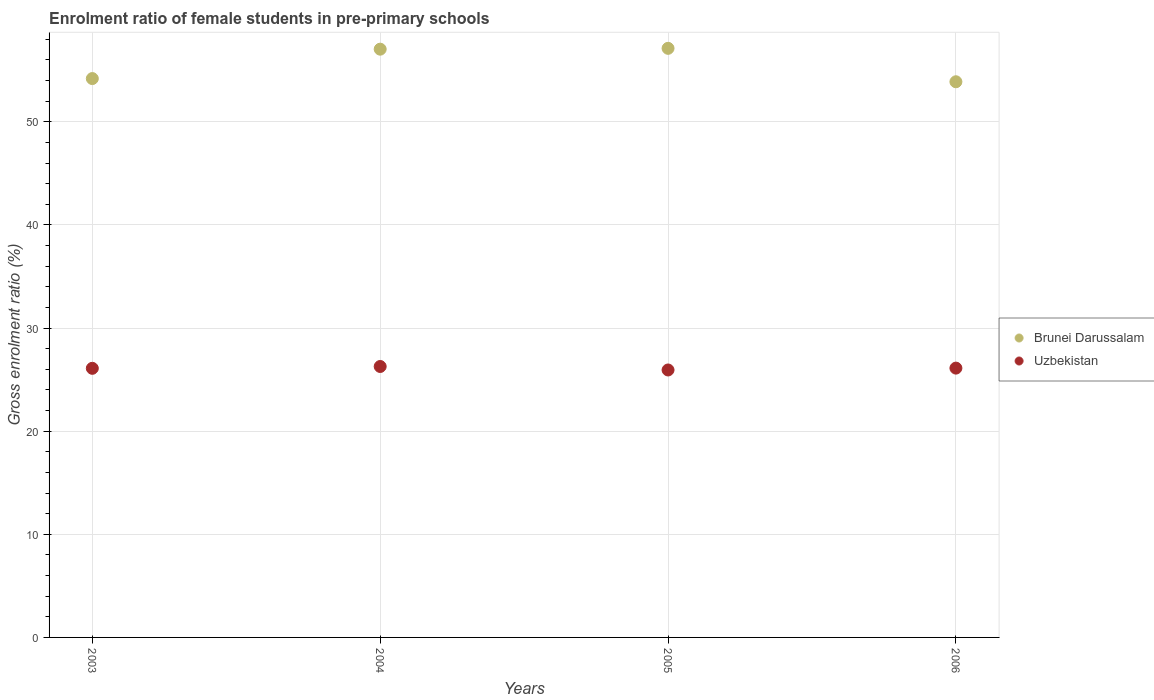Is the number of dotlines equal to the number of legend labels?
Offer a terse response. Yes. What is the enrolment ratio of female students in pre-primary schools in Brunei Darussalam in 2004?
Your response must be concise. 57.04. Across all years, what is the maximum enrolment ratio of female students in pre-primary schools in Brunei Darussalam?
Give a very brief answer. 57.12. Across all years, what is the minimum enrolment ratio of female students in pre-primary schools in Uzbekistan?
Offer a very short reply. 25.93. What is the total enrolment ratio of female students in pre-primary schools in Uzbekistan in the graph?
Make the answer very short. 104.41. What is the difference between the enrolment ratio of female students in pre-primary schools in Uzbekistan in 2003 and that in 2006?
Ensure brevity in your answer.  -0.02. What is the difference between the enrolment ratio of female students in pre-primary schools in Uzbekistan in 2006 and the enrolment ratio of female students in pre-primary schools in Brunei Darussalam in 2004?
Keep it short and to the point. -30.92. What is the average enrolment ratio of female students in pre-primary schools in Brunei Darussalam per year?
Give a very brief answer. 55.56. In the year 2005, what is the difference between the enrolment ratio of female students in pre-primary schools in Brunei Darussalam and enrolment ratio of female students in pre-primary schools in Uzbekistan?
Provide a succinct answer. 31.19. In how many years, is the enrolment ratio of female students in pre-primary schools in Uzbekistan greater than 2 %?
Your response must be concise. 4. What is the ratio of the enrolment ratio of female students in pre-primary schools in Uzbekistan in 2004 to that in 2005?
Your answer should be compact. 1.01. What is the difference between the highest and the second highest enrolment ratio of female students in pre-primary schools in Uzbekistan?
Your answer should be very brief. 0.16. What is the difference between the highest and the lowest enrolment ratio of female students in pre-primary schools in Uzbekistan?
Provide a succinct answer. 0.34. In how many years, is the enrolment ratio of female students in pre-primary schools in Brunei Darussalam greater than the average enrolment ratio of female students in pre-primary schools in Brunei Darussalam taken over all years?
Offer a very short reply. 2. Does the enrolment ratio of female students in pre-primary schools in Uzbekistan monotonically increase over the years?
Offer a terse response. No. Is the enrolment ratio of female students in pre-primary schools in Uzbekistan strictly less than the enrolment ratio of female students in pre-primary schools in Brunei Darussalam over the years?
Offer a terse response. Yes. How many dotlines are there?
Offer a terse response. 2. How many years are there in the graph?
Provide a short and direct response. 4. What is the difference between two consecutive major ticks on the Y-axis?
Ensure brevity in your answer.  10. Are the values on the major ticks of Y-axis written in scientific E-notation?
Provide a short and direct response. No. Does the graph contain any zero values?
Your answer should be compact. No. Where does the legend appear in the graph?
Give a very brief answer. Center right. How many legend labels are there?
Provide a short and direct response. 2. How are the legend labels stacked?
Make the answer very short. Vertical. What is the title of the graph?
Keep it short and to the point. Enrolment ratio of female students in pre-primary schools. Does "Djibouti" appear as one of the legend labels in the graph?
Make the answer very short. No. What is the label or title of the X-axis?
Your answer should be very brief. Years. What is the Gross enrolment ratio (%) of Brunei Darussalam in 2003?
Keep it short and to the point. 54.19. What is the Gross enrolment ratio (%) in Uzbekistan in 2003?
Make the answer very short. 26.09. What is the Gross enrolment ratio (%) of Brunei Darussalam in 2004?
Give a very brief answer. 57.04. What is the Gross enrolment ratio (%) of Uzbekistan in 2004?
Your response must be concise. 26.27. What is the Gross enrolment ratio (%) in Brunei Darussalam in 2005?
Make the answer very short. 57.12. What is the Gross enrolment ratio (%) in Uzbekistan in 2005?
Give a very brief answer. 25.93. What is the Gross enrolment ratio (%) of Brunei Darussalam in 2006?
Ensure brevity in your answer.  53.88. What is the Gross enrolment ratio (%) of Uzbekistan in 2006?
Make the answer very short. 26.11. Across all years, what is the maximum Gross enrolment ratio (%) in Brunei Darussalam?
Your answer should be compact. 57.12. Across all years, what is the maximum Gross enrolment ratio (%) of Uzbekistan?
Make the answer very short. 26.27. Across all years, what is the minimum Gross enrolment ratio (%) in Brunei Darussalam?
Give a very brief answer. 53.88. Across all years, what is the minimum Gross enrolment ratio (%) of Uzbekistan?
Your response must be concise. 25.93. What is the total Gross enrolment ratio (%) of Brunei Darussalam in the graph?
Give a very brief answer. 222.22. What is the total Gross enrolment ratio (%) in Uzbekistan in the graph?
Provide a succinct answer. 104.41. What is the difference between the Gross enrolment ratio (%) of Brunei Darussalam in 2003 and that in 2004?
Ensure brevity in your answer.  -2.85. What is the difference between the Gross enrolment ratio (%) of Uzbekistan in 2003 and that in 2004?
Keep it short and to the point. -0.18. What is the difference between the Gross enrolment ratio (%) of Brunei Darussalam in 2003 and that in 2005?
Your response must be concise. -2.93. What is the difference between the Gross enrolment ratio (%) in Uzbekistan in 2003 and that in 2005?
Your answer should be very brief. 0.16. What is the difference between the Gross enrolment ratio (%) of Brunei Darussalam in 2003 and that in 2006?
Keep it short and to the point. 0.31. What is the difference between the Gross enrolment ratio (%) of Uzbekistan in 2003 and that in 2006?
Your response must be concise. -0.02. What is the difference between the Gross enrolment ratio (%) of Brunei Darussalam in 2004 and that in 2005?
Ensure brevity in your answer.  -0.08. What is the difference between the Gross enrolment ratio (%) of Uzbekistan in 2004 and that in 2005?
Your answer should be compact. 0.34. What is the difference between the Gross enrolment ratio (%) in Brunei Darussalam in 2004 and that in 2006?
Make the answer very short. 3.16. What is the difference between the Gross enrolment ratio (%) of Uzbekistan in 2004 and that in 2006?
Give a very brief answer. 0.16. What is the difference between the Gross enrolment ratio (%) in Brunei Darussalam in 2005 and that in 2006?
Keep it short and to the point. 3.24. What is the difference between the Gross enrolment ratio (%) of Uzbekistan in 2005 and that in 2006?
Your answer should be compact. -0.18. What is the difference between the Gross enrolment ratio (%) in Brunei Darussalam in 2003 and the Gross enrolment ratio (%) in Uzbekistan in 2004?
Your response must be concise. 27.92. What is the difference between the Gross enrolment ratio (%) in Brunei Darussalam in 2003 and the Gross enrolment ratio (%) in Uzbekistan in 2005?
Your answer should be very brief. 28.25. What is the difference between the Gross enrolment ratio (%) in Brunei Darussalam in 2003 and the Gross enrolment ratio (%) in Uzbekistan in 2006?
Ensure brevity in your answer.  28.07. What is the difference between the Gross enrolment ratio (%) in Brunei Darussalam in 2004 and the Gross enrolment ratio (%) in Uzbekistan in 2005?
Your answer should be compact. 31.11. What is the difference between the Gross enrolment ratio (%) in Brunei Darussalam in 2004 and the Gross enrolment ratio (%) in Uzbekistan in 2006?
Provide a succinct answer. 30.92. What is the difference between the Gross enrolment ratio (%) in Brunei Darussalam in 2005 and the Gross enrolment ratio (%) in Uzbekistan in 2006?
Give a very brief answer. 31.01. What is the average Gross enrolment ratio (%) in Brunei Darussalam per year?
Keep it short and to the point. 55.56. What is the average Gross enrolment ratio (%) in Uzbekistan per year?
Offer a terse response. 26.1. In the year 2003, what is the difference between the Gross enrolment ratio (%) in Brunei Darussalam and Gross enrolment ratio (%) in Uzbekistan?
Keep it short and to the point. 28.09. In the year 2004, what is the difference between the Gross enrolment ratio (%) of Brunei Darussalam and Gross enrolment ratio (%) of Uzbekistan?
Your answer should be compact. 30.77. In the year 2005, what is the difference between the Gross enrolment ratio (%) in Brunei Darussalam and Gross enrolment ratio (%) in Uzbekistan?
Give a very brief answer. 31.19. In the year 2006, what is the difference between the Gross enrolment ratio (%) in Brunei Darussalam and Gross enrolment ratio (%) in Uzbekistan?
Keep it short and to the point. 27.76. What is the ratio of the Gross enrolment ratio (%) of Brunei Darussalam in 2003 to that in 2004?
Your response must be concise. 0.95. What is the ratio of the Gross enrolment ratio (%) in Uzbekistan in 2003 to that in 2004?
Offer a very short reply. 0.99. What is the ratio of the Gross enrolment ratio (%) of Brunei Darussalam in 2003 to that in 2005?
Your answer should be very brief. 0.95. What is the ratio of the Gross enrolment ratio (%) of Brunei Darussalam in 2004 to that in 2005?
Offer a terse response. 1. What is the ratio of the Gross enrolment ratio (%) in Uzbekistan in 2004 to that in 2005?
Provide a succinct answer. 1.01. What is the ratio of the Gross enrolment ratio (%) of Brunei Darussalam in 2004 to that in 2006?
Provide a succinct answer. 1.06. What is the ratio of the Gross enrolment ratio (%) in Brunei Darussalam in 2005 to that in 2006?
Ensure brevity in your answer.  1.06. What is the ratio of the Gross enrolment ratio (%) in Uzbekistan in 2005 to that in 2006?
Your response must be concise. 0.99. What is the difference between the highest and the second highest Gross enrolment ratio (%) in Brunei Darussalam?
Provide a succinct answer. 0.08. What is the difference between the highest and the second highest Gross enrolment ratio (%) of Uzbekistan?
Ensure brevity in your answer.  0.16. What is the difference between the highest and the lowest Gross enrolment ratio (%) in Brunei Darussalam?
Give a very brief answer. 3.24. What is the difference between the highest and the lowest Gross enrolment ratio (%) in Uzbekistan?
Offer a very short reply. 0.34. 